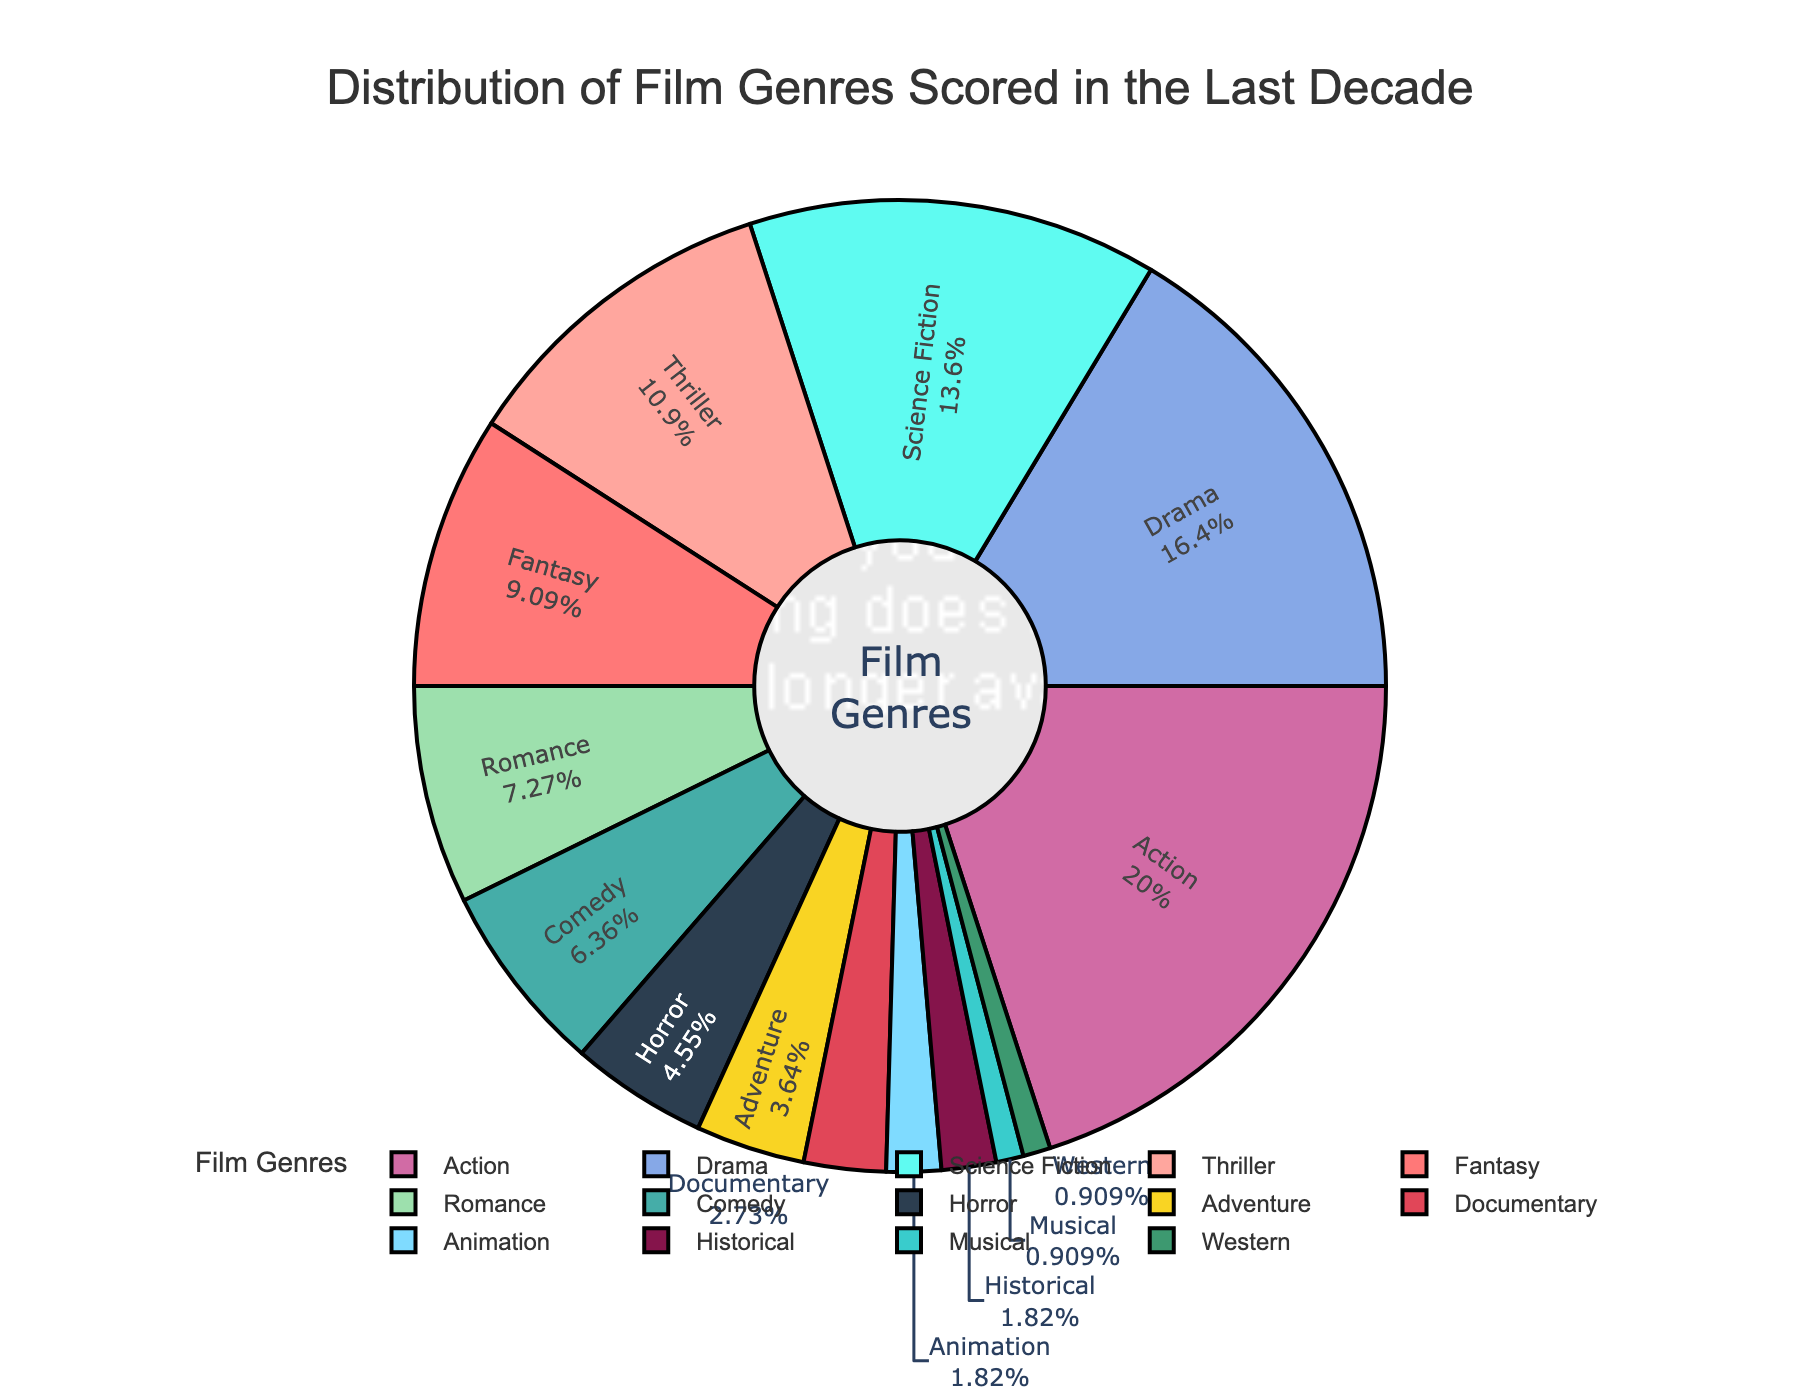Which genre has the largest share? The figure shows the distribution of film genres by percentage. The genre with the largest slice is labeled "Action" with 22%.
Answer: Action How much more percentage does the Action genre have compared to the Horror genre? The figure shows Action at 22% and Horror at 5%. Subtracting the percentages (22% - 5%) gives us the difference.
Answer: 17% What is the combined percentage of Drama and Science Fiction genres? The figure lists Drama at 18% and Science Fiction at 15%. Adding these percentages (18% + 15%) gives us the combined value.
Answer: 33% Which genre has the smallest share and what is its percentage? The figure shows the smallest slice labeled "Musical" and "Western", each with 1%.
Answer: Musical and Western, 1% How do the percentages of Thriller and Fantasy compare? The figure lists Thriller at 12% and Fantasy at 10%. Thriller has a 2% higher share than Fantasy.
Answer: Thriller is higher, by 2% What's the total percentage for genres with a share of 5% or less? The genres Horror (5%), Adventure (4%), Documentary (3%), Animation (2%), Historical (2%), Musical (1%), and Western (1%) sum up to 5 + 4 + 3 + 2 + 2 + 1 + 1 = 18%.
Answer: 18% What is the percentage difference between Comedy and Romance? Comedy is at 7% and Romance is at 8%, so the difference is 8% - 7%.
Answer: 1% Which colors are used for Action and Romance genres, and do they visually stand out in the pie chart? The figure likely uses distinct colors for visual differentiation. Action is represented by the first color in the sequence, and Romance is further down the list. Without the exact colors mentioned, we infer these genres use visually distinct colors based on their percentages.
Answer: Distinct colors for both; Action stands out more due to a larger percentage 